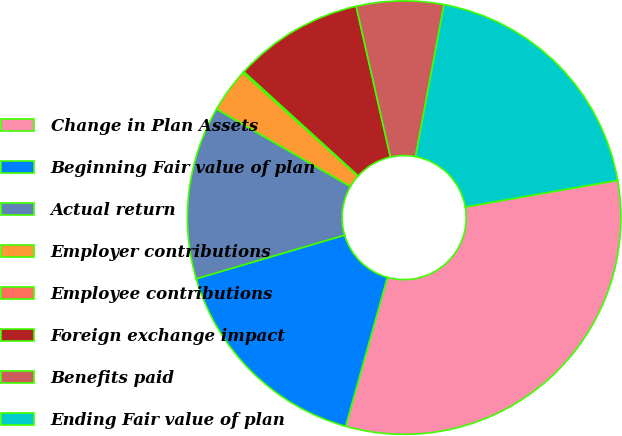<chart> <loc_0><loc_0><loc_500><loc_500><pie_chart><fcel>Change in Plan Assets<fcel>Beginning Fair value of plan<fcel>Actual return<fcel>Employer contributions<fcel>Employee contributions<fcel>Foreign exchange impact<fcel>Benefits paid<fcel>Ending Fair value of plan<nl><fcel>32.11%<fcel>16.1%<fcel>12.9%<fcel>3.3%<fcel>0.1%<fcel>9.7%<fcel>6.5%<fcel>19.3%<nl></chart> 